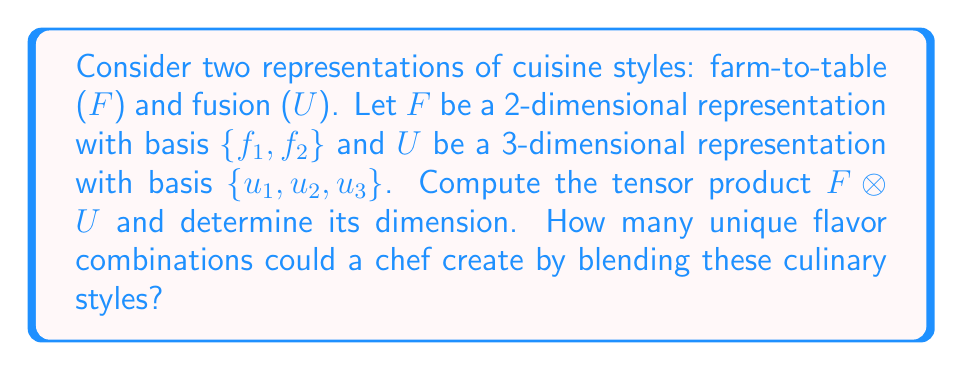Can you answer this question? To compute the tensor product $F \otimes U$ and determine its dimension, we follow these steps:

1) The tensor product of two vector spaces is formed by taking all possible products of basis vectors from each space.

2) For $F \otimes U$, we have:
   $$F \otimes U = \{f_i \otimes u_j \mid i = 1,2; j = 1,2,3\}$$

3) This gives us the following basis vectors:
   $$\{f_1 \otimes u_1, f_1 \otimes u_2, f_1 \otimes u_3, f_2 \otimes u_1, f_2 \otimes u_2, f_2 \otimes u_3\}$$

4) To determine the dimension of $F \otimes U$, we count the number of basis vectors:
   $$\dim(F \otimes U) = \dim(F) \times \dim(U) = 2 \times 3 = 6$$

5) Each basis vector in the tensor product represents a unique combination of the farm-to-table and fusion styles. Therefore, the number of unique flavor combinations a chef could create by blending these culinary styles is equal to the dimension of the tensor product.
Answer: 6 unique flavor combinations 